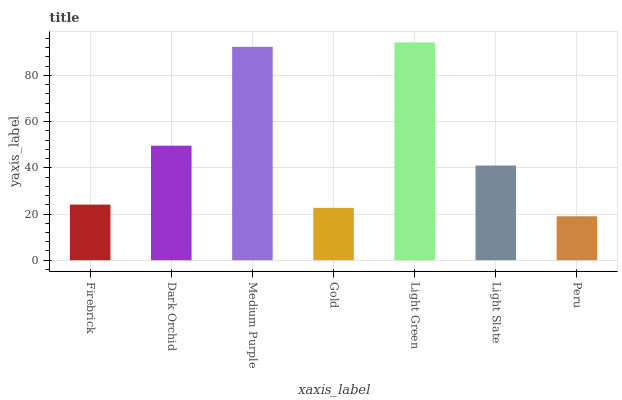Is Peru the minimum?
Answer yes or no. Yes. Is Light Green the maximum?
Answer yes or no. Yes. Is Dark Orchid the minimum?
Answer yes or no. No. Is Dark Orchid the maximum?
Answer yes or no. No. Is Dark Orchid greater than Firebrick?
Answer yes or no. Yes. Is Firebrick less than Dark Orchid?
Answer yes or no. Yes. Is Firebrick greater than Dark Orchid?
Answer yes or no. No. Is Dark Orchid less than Firebrick?
Answer yes or no. No. Is Light Slate the high median?
Answer yes or no. Yes. Is Light Slate the low median?
Answer yes or no. Yes. Is Light Green the high median?
Answer yes or no. No. Is Gold the low median?
Answer yes or no. No. 